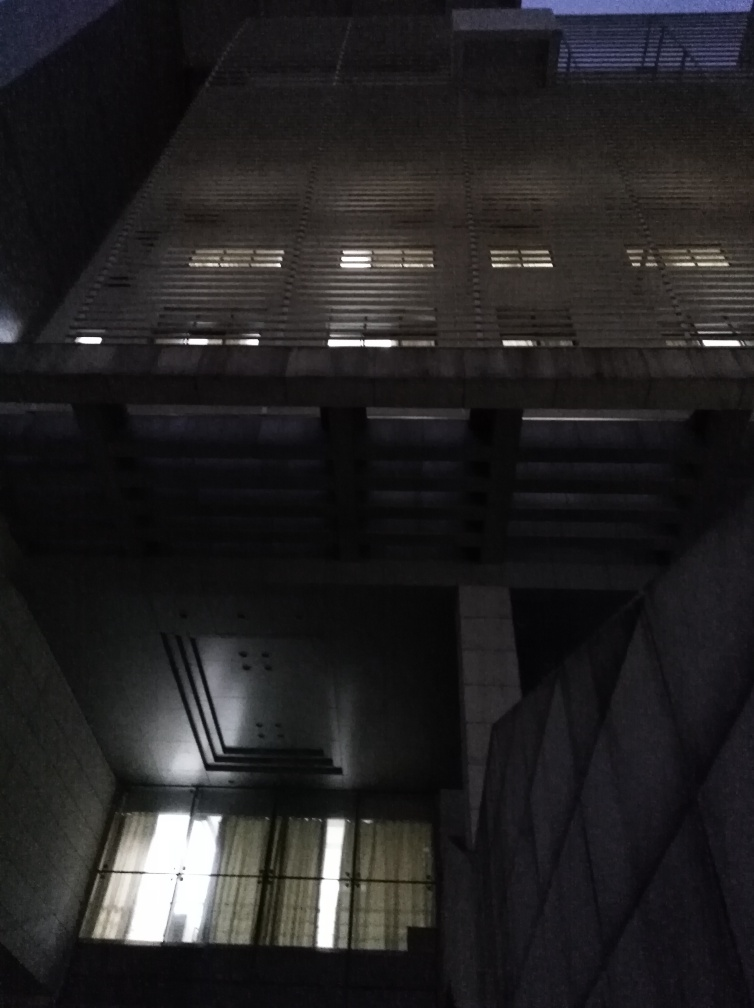What can be said about the overall composition and texture details? The composition of the image presents a strong geometric aspect accentuated by the vertical and horizontal lines created by the structure of the building and its windows. The lighting is minimal, offering a brooding aesthetic that may invoke a sense of solitude or somberness. The texture of the building's facade is somewhat discernible due to the low light, hinting at what may be a rough or industrial material, but details are not clearly visible, creating an air of mystery about the building's character. 